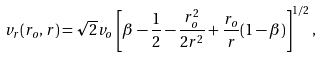<formula> <loc_0><loc_0><loc_500><loc_500>v _ { r } ( r _ { o } , r ) = \sqrt { 2 } v _ { o } \left [ \beta - \frac { 1 } { 2 } - \frac { r _ { o } ^ { 2 } } { 2 r ^ { 2 } } + \frac { r _ { o } } { r } ( 1 - \beta ) \right ] ^ { 1 / 2 } ,</formula> 